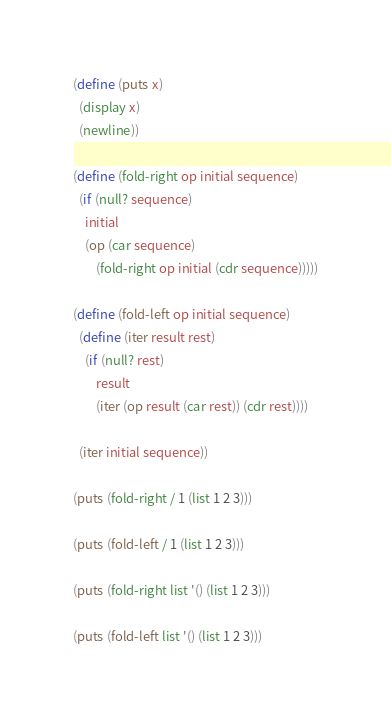Convert code to text. <code><loc_0><loc_0><loc_500><loc_500><_Scheme_>(define (puts x)
  (display x)
  (newline))

(define (fold-right op initial sequence)
  (if (null? sequence)
    initial
    (op (car sequence)
        (fold-right op initial (cdr sequence)))))

(define (fold-left op initial sequence)
  (define (iter result rest)
    (if (null? rest)
        result
        (iter (op result (car rest)) (cdr rest))))

  (iter initial sequence))

(puts (fold-right / 1 (list 1 2 3)))

(puts (fold-left / 1 (list 1 2 3)))

(puts (fold-right list '() (list 1 2 3)))

(puts (fold-left list '() (list 1 2 3)))
</code> 